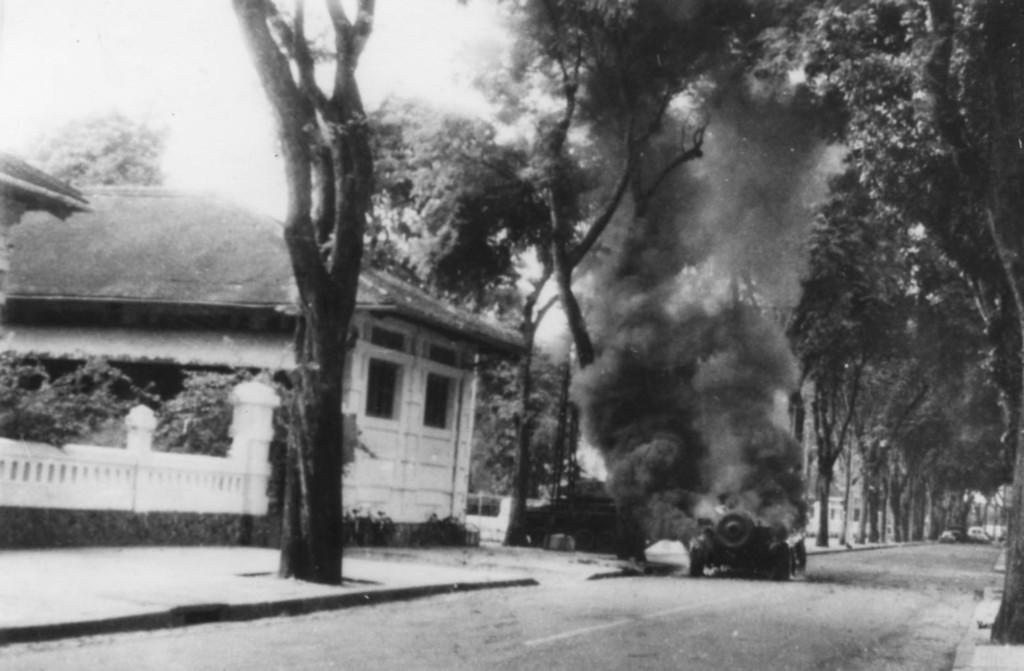In one or two sentences, can you explain what this image depicts? It is a black and white image, on the left side there is a house. This is the road, in the middle a vehicle is burning, these are the trees 